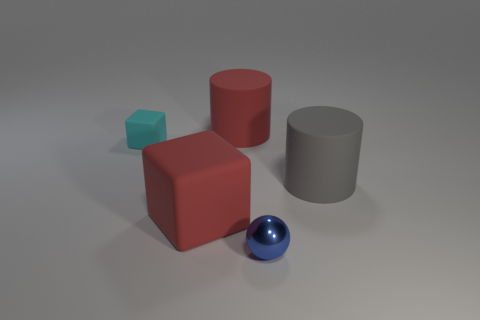Are there the same number of gray rubber cylinders and large blue metal objects?
Provide a short and direct response. No. There is a matte object to the right of the blue object; is its shape the same as the big red rubber object that is behind the small cyan rubber cube?
Your answer should be compact. Yes. Are there any large brown spheres made of the same material as the small ball?
Offer a very short reply. No. What number of green things are shiny objects or rubber cylinders?
Keep it short and to the point. 0. How big is the rubber thing that is in front of the cyan object and on the right side of the big red cube?
Make the answer very short. Large. Is the number of gray things to the left of the red cylinder greater than the number of small metallic spheres?
Offer a terse response. No. How many cylinders are small blue objects or big red objects?
Your answer should be very brief. 1. There is a object that is both behind the gray matte cylinder and on the right side of the cyan rubber thing; what is its shape?
Make the answer very short. Cylinder. Are there an equal number of red cubes that are to the right of the metallic ball and tiny things on the right side of the tiny block?
Your response must be concise. No. How many things are either large purple metallic spheres or small objects?
Give a very brief answer. 2. 